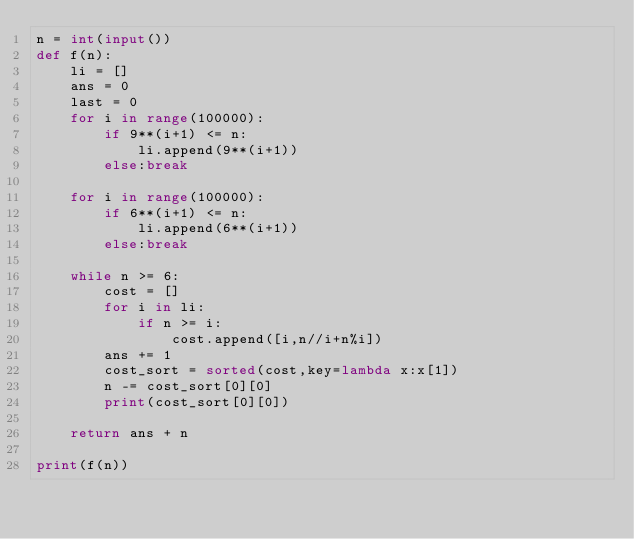Convert code to text. <code><loc_0><loc_0><loc_500><loc_500><_Python_>n = int(input())
def f(n):
    li = []
    ans = 0
    last = 0
    for i in range(100000):
        if 9**(i+1) <= n:
            li.append(9**(i+1))
        else:break
    
    for i in range(100000):
        if 6**(i+1) <= n:
            li.append(6**(i+1))
        else:break
    
    while n >= 6:
        cost = []
        for i in li:
            if n >= i:
                cost.append([i,n//i+n%i])
        ans += 1
        cost_sort = sorted(cost,key=lambda x:x[1])
        n -= cost_sort[0][0]
        print(cost_sort[0][0])

    return ans + n

print(f(n))</code> 